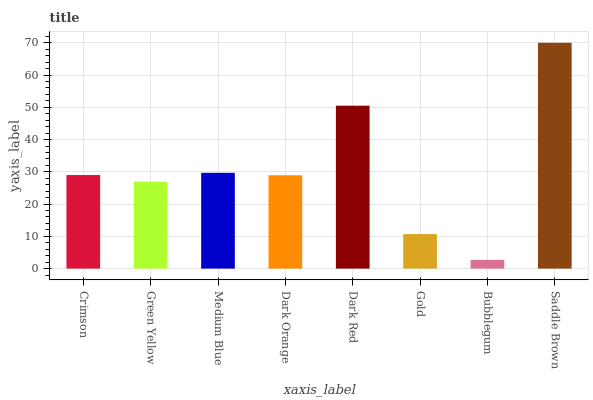Is Bubblegum the minimum?
Answer yes or no. Yes. Is Saddle Brown the maximum?
Answer yes or no. Yes. Is Green Yellow the minimum?
Answer yes or no. No. Is Green Yellow the maximum?
Answer yes or no. No. Is Crimson greater than Green Yellow?
Answer yes or no. Yes. Is Green Yellow less than Crimson?
Answer yes or no. Yes. Is Green Yellow greater than Crimson?
Answer yes or no. No. Is Crimson less than Green Yellow?
Answer yes or no. No. Is Crimson the high median?
Answer yes or no. Yes. Is Dark Orange the low median?
Answer yes or no. Yes. Is Saddle Brown the high median?
Answer yes or no. No. Is Gold the low median?
Answer yes or no. No. 